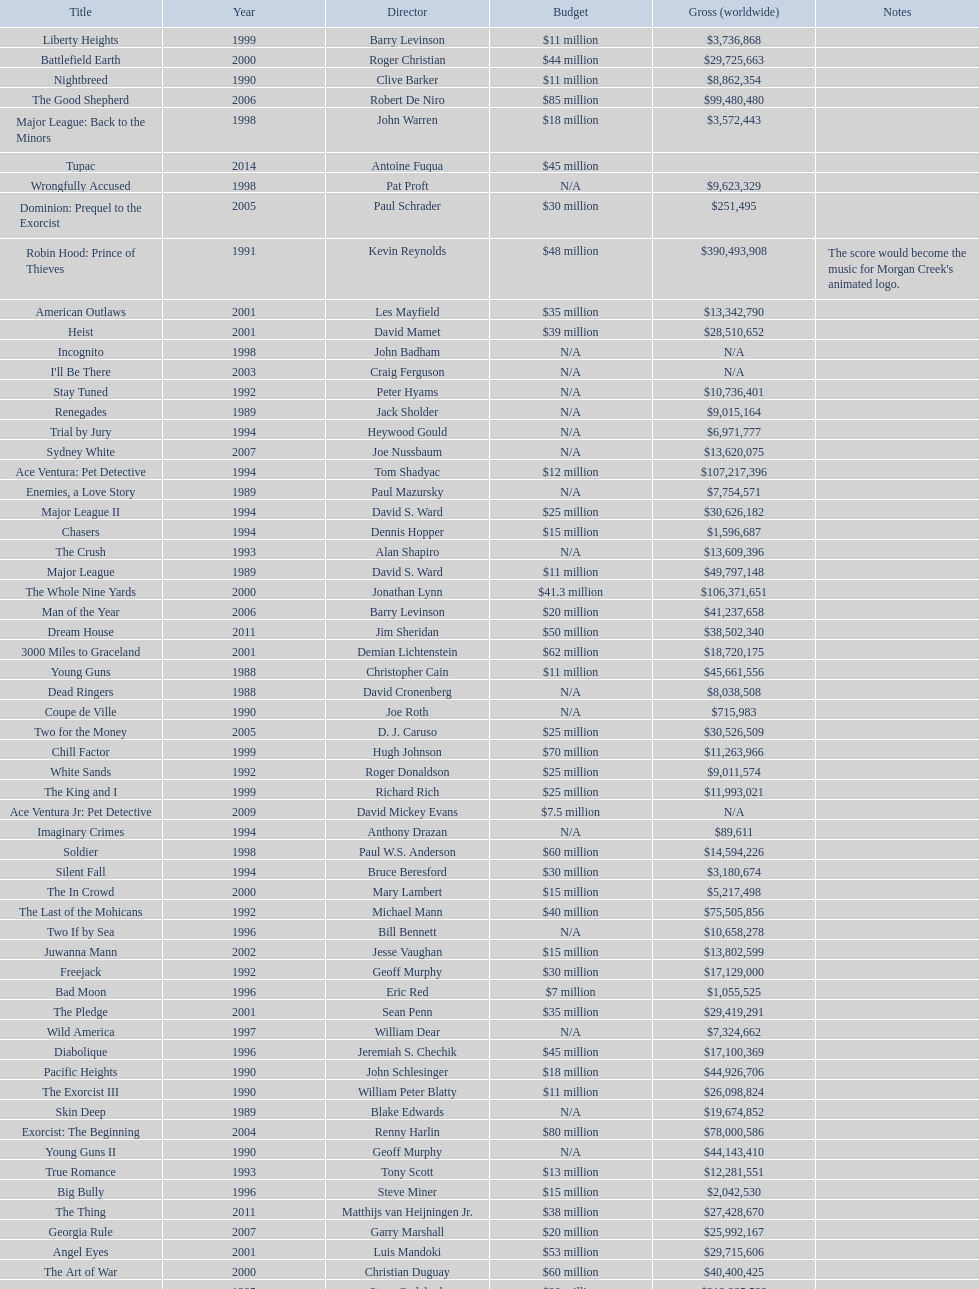Which film had a higher budget, ace ventura: when nature calls, or major league: back to the minors? Ace Ventura: When Nature Calls. 